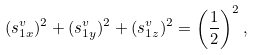Convert formula to latex. <formula><loc_0><loc_0><loc_500><loc_500>( s _ { 1 x } ^ { v } ) ^ { 2 } + ( s _ { 1 y } ^ { v } ) ^ { 2 } + ( s _ { 1 z } ^ { v } ) ^ { 2 } = \left ( \frac { 1 } { 2 } \right ) ^ { 2 } ,</formula> 